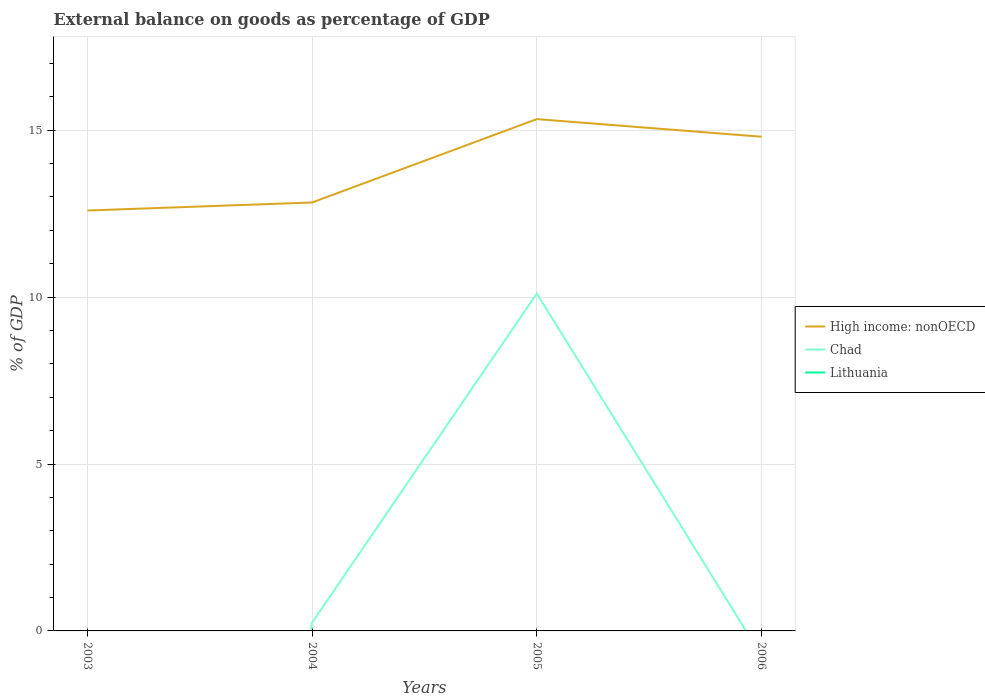How many different coloured lines are there?
Provide a short and direct response. 2. Does the line corresponding to High income: nonOECD intersect with the line corresponding to Lithuania?
Provide a succinct answer. No. Is the number of lines equal to the number of legend labels?
Provide a short and direct response. No. Across all years, what is the maximum external balance on goods as percentage of GDP in High income: nonOECD?
Your answer should be very brief. 12.59. What is the total external balance on goods as percentage of GDP in High income: nonOECD in the graph?
Ensure brevity in your answer.  -0.24. What is the difference between the highest and the second highest external balance on goods as percentage of GDP in High income: nonOECD?
Your answer should be compact. 2.74. Is the external balance on goods as percentage of GDP in Chad strictly greater than the external balance on goods as percentage of GDP in Lithuania over the years?
Give a very brief answer. No. How many lines are there?
Offer a very short reply. 2. What is the difference between two consecutive major ticks on the Y-axis?
Provide a succinct answer. 5. Are the values on the major ticks of Y-axis written in scientific E-notation?
Give a very brief answer. No. Does the graph contain grids?
Your answer should be compact. Yes. How many legend labels are there?
Provide a succinct answer. 3. How are the legend labels stacked?
Your answer should be compact. Vertical. What is the title of the graph?
Give a very brief answer. External balance on goods as percentage of GDP. Does "Dominica" appear as one of the legend labels in the graph?
Keep it short and to the point. No. What is the label or title of the X-axis?
Provide a short and direct response. Years. What is the label or title of the Y-axis?
Offer a very short reply. % of GDP. What is the % of GDP in High income: nonOECD in 2003?
Provide a short and direct response. 12.59. What is the % of GDP in Chad in 2003?
Offer a very short reply. 0. What is the % of GDP of Lithuania in 2003?
Your answer should be compact. 0. What is the % of GDP in High income: nonOECD in 2004?
Ensure brevity in your answer.  12.83. What is the % of GDP in Chad in 2004?
Offer a terse response. 0.25. What is the % of GDP in High income: nonOECD in 2005?
Provide a succinct answer. 15.33. What is the % of GDP of Chad in 2005?
Provide a short and direct response. 10.11. What is the % of GDP of Lithuania in 2005?
Your answer should be compact. 0. What is the % of GDP in High income: nonOECD in 2006?
Give a very brief answer. 14.8. What is the % of GDP of Lithuania in 2006?
Offer a terse response. 0. Across all years, what is the maximum % of GDP of High income: nonOECD?
Your answer should be very brief. 15.33. Across all years, what is the maximum % of GDP in Chad?
Offer a very short reply. 10.11. Across all years, what is the minimum % of GDP of High income: nonOECD?
Give a very brief answer. 12.59. Across all years, what is the minimum % of GDP in Chad?
Ensure brevity in your answer.  0. What is the total % of GDP of High income: nonOECD in the graph?
Offer a very short reply. 55.56. What is the total % of GDP in Chad in the graph?
Give a very brief answer. 10.36. What is the total % of GDP of Lithuania in the graph?
Ensure brevity in your answer.  0. What is the difference between the % of GDP in High income: nonOECD in 2003 and that in 2004?
Give a very brief answer. -0.24. What is the difference between the % of GDP in High income: nonOECD in 2003 and that in 2005?
Give a very brief answer. -2.74. What is the difference between the % of GDP of High income: nonOECD in 2003 and that in 2006?
Your answer should be very brief. -2.21. What is the difference between the % of GDP in High income: nonOECD in 2004 and that in 2005?
Your answer should be very brief. -2.5. What is the difference between the % of GDP of Chad in 2004 and that in 2005?
Provide a short and direct response. -9.86. What is the difference between the % of GDP of High income: nonOECD in 2004 and that in 2006?
Your answer should be very brief. -1.97. What is the difference between the % of GDP in High income: nonOECD in 2005 and that in 2006?
Your response must be concise. 0.53. What is the difference between the % of GDP in High income: nonOECD in 2003 and the % of GDP in Chad in 2004?
Your response must be concise. 12.34. What is the difference between the % of GDP in High income: nonOECD in 2003 and the % of GDP in Chad in 2005?
Keep it short and to the point. 2.49. What is the difference between the % of GDP in High income: nonOECD in 2004 and the % of GDP in Chad in 2005?
Keep it short and to the point. 2.73. What is the average % of GDP in High income: nonOECD per year?
Offer a very short reply. 13.89. What is the average % of GDP in Chad per year?
Offer a terse response. 2.59. In the year 2004, what is the difference between the % of GDP of High income: nonOECD and % of GDP of Chad?
Ensure brevity in your answer.  12.58. In the year 2005, what is the difference between the % of GDP in High income: nonOECD and % of GDP in Chad?
Offer a terse response. 5.22. What is the ratio of the % of GDP in High income: nonOECD in 2003 to that in 2004?
Your answer should be compact. 0.98. What is the ratio of the % of GDP of High income: nonOECD in 2003 to that in 2005?
Your answer should be very brief. 0.82. What is the ratio of the % of GDP of High income: nonOECD in 2003 to that in 2006?
Ensure brevity in your answer.  0.85. What is the ratio of the % of GDP of High income: nonOECD in 2004 to that in 2005?
Provide a succinct answer. 0.84. What is the ratio of the % of GDP of Chad in 2004 to that in 2005?
Provide a short and direct response. 0.02. What is the ratio of the % of GDP in High income: nonOECD in 2004 to that in 2006?
Your answer should be very brief. 0.87. What is the ratio of the % of GDP in High income: nonOECD in 2005 to that in 2006?
Provide a succinct answer. 1.04. What is the difference between the highest and the second highest % of GDP of High income: nonOECD?
Offer a very short reply. 0.53. What is the difference between the highest and the lowest % of GDP in High income: nonOECD?
Ensure brevity in your answer.  2.74. What is the difference between the highest and the lowest % of GDP of Chad?
Ensure brevity in your answer.  10.11. 